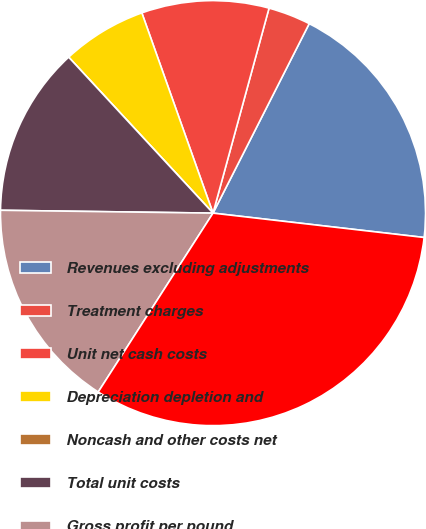Convert chart. <chart><loc_0><loc_0><loc_500><loc_500><pie_chart><fcel>Revenues excluding adjustments<fcel>Treatment charges<fcel>Unit net cash costs<fcel>Depreciation depletion and<fcel>Noncash and other costs net<fcel>Total unit costs<fcel>Gross profit per pound<fcel>Copper sales (millions of<nl><fcel>19.35%<fcel>3.23%<fcel>9.68%<fcel>6.45%<fcel>0.0%<fcel>12.9%<fcel>16.13%<fcel>32.25%<nl></chart> 